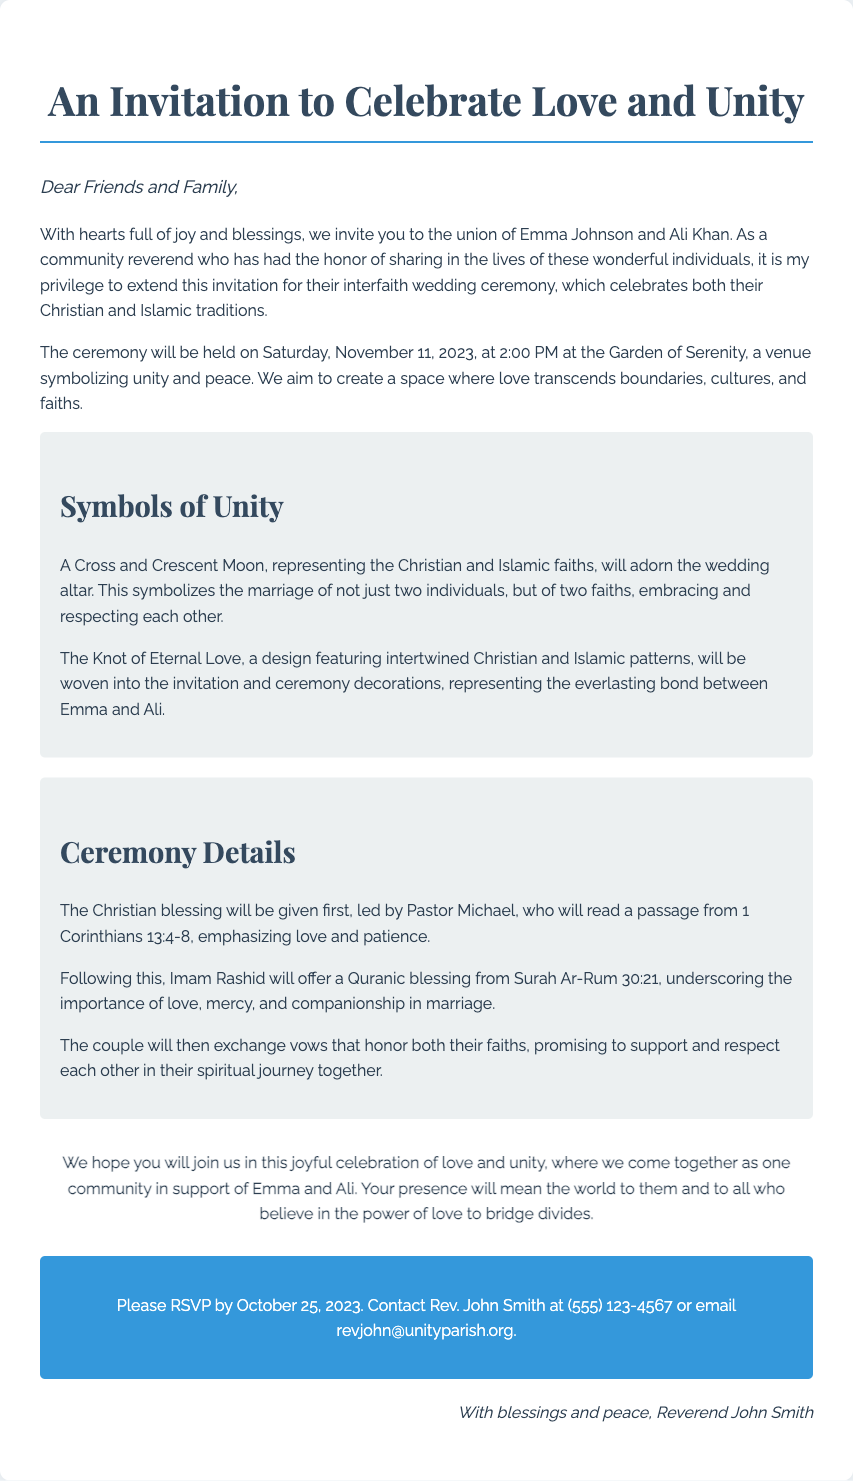What are the names of the couple getting married? The document explicitly states the names of the couple, which are Emma Johnson and Ali Khan.
Answer: Emma Johnson and Ali Khan What is the date of the wedding ceremony? The specific date for the wedding ceremony is mentioned in the document.
Answer: November 11, 2023 Who will provide the Christian blessing? The document specifies who will give the Christian blessing as Pastor Michael.
Answer: Pastor Michael What is the name of the venue for the ceremony? The venue where the ceremony will take place is clearly outlined in the document.
Answer: Garden of Serenity What symbol will represent both faiths at the altar? The document describes a specific symbol that will appear at the wedding altar.
Answer: A Cross and Crescent Moon What passage will Pastor Michael read? The passage that Pastor Michael will read during the ceremony is also mentioned in the document.
Answer: 1 Corinthians 13:4-8 Who should be contacted for RSVPs? The document indicates who to contact for RSVPs and provides their title.
Answer: Rev. John Smith How does the couple plan to exchange vows? The document details how the couple intends to exchange vows during the ceremony.
Answer: Honoring both their faiths 